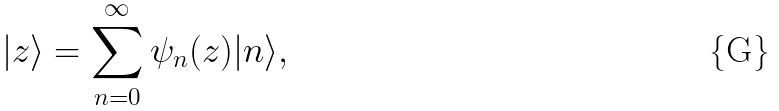<formula> <loc_0><loc_0><loc_500><loc_500>| z \rangle = \sum _ { n = 0 } ^ { \infty } \psi _ { n } ( z ) | n \rangle ,</formula> 